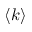Convert formula to latex. <formula><loc_0><loc_0><loc_500><loc_500>\langle k \rangle</formula> 